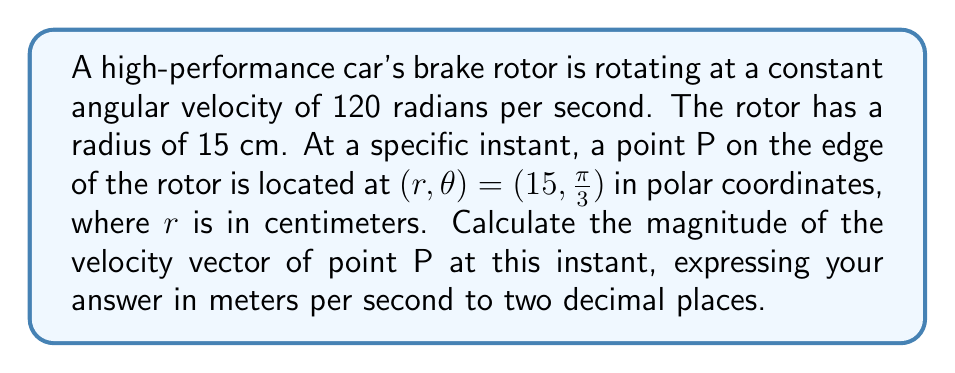Provide a solution to this math problem. Let's approach this step-by-step:

1) In polar coordinates, the position vector of a point is given by:
   $$\vec{r} = r\hat{r}$$
   where $\hat{r}$ is the unit vector in the radial direction.

2) The velocity vector in polar coordinates is:
   $$\vec{v} = \frac{dr}{dt}\hat{r} + r\frac{d\theta}{dt}\hat{\theta}$$
   where $\hat{\theta}$ is the unit vector in the angular direction.

3) In this case, $\frac{dr}{dt} = 0$ (the radius is constant), and $\frac{d\theta}{dt} = \omega$ (the angular velocity).

4) So, the velocity vector simplifies to:
   $$\vec{v} = r\omega\hat{\theta}$$

5) The magnitude of this vector is:
   $$|\vec{v}| = r\omega$$

6) We're given:
   $r = 15$ cm = $0.15$ m
   $\omega = 120$ rad/s

7) Substituting these values:
   $$|\vec{v}| = 0.15 \text{ m} \times 120 \text{ rad/s} = 18 \text{ m/s}$$

8) Rounding to two decimal places: $18.00$ m/s

Note: The specific angular position $(\frac{\pi}{3})$ doesn't affect the magnitude of the velocity, as the angular velocity is constant.
Answer: $18.00$ m/s 